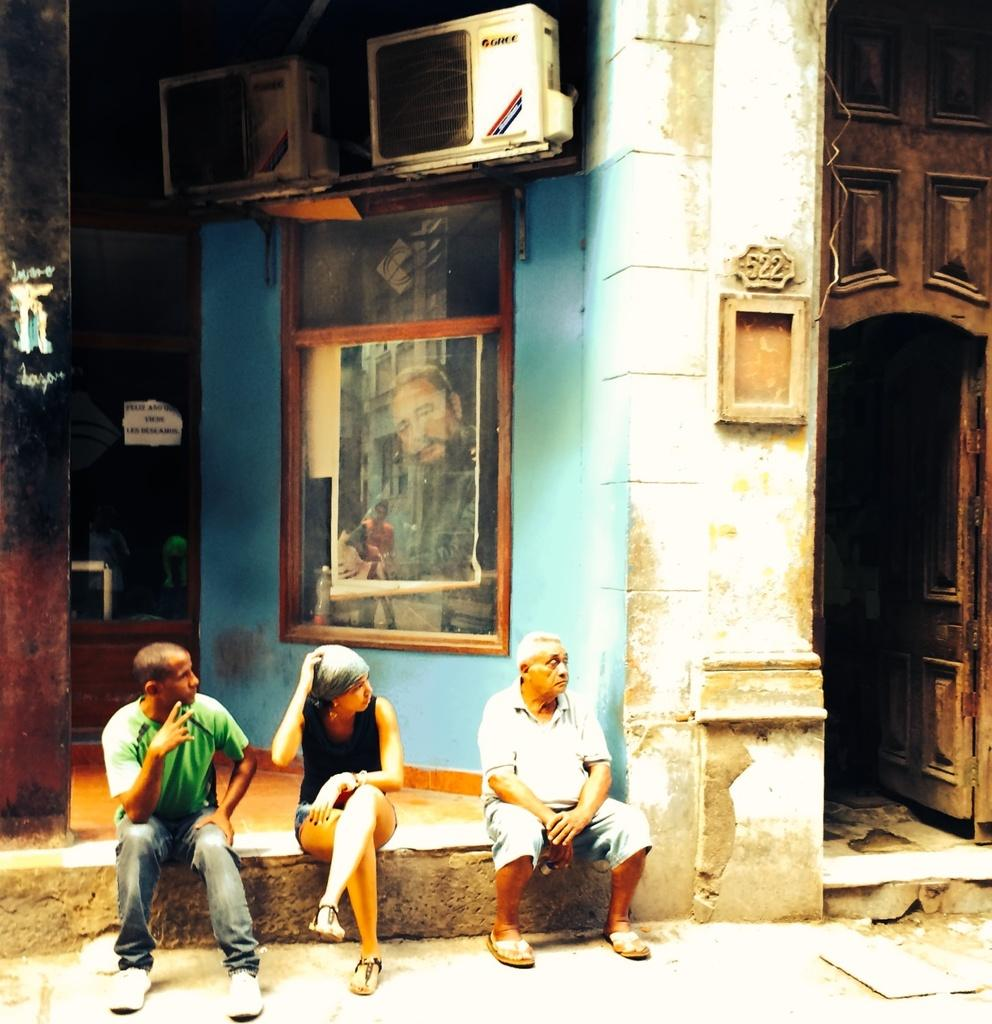What are the persons in the image sitting on? The persons in the image are sitting on stone. What can be seen on the wall in the image? There is a frame on the wall. What is located on the top of the wall in the image? There is an AC outdoor unit on the top of the wall. What is on the left side of the image? There is a door on the left side of the image. What type of drum is being played by the persons in the image? There is no drum present in the image; the persons are sitting on stone. What color is the collar of the cherry in the image? There is no cherry or collar present in the image. 